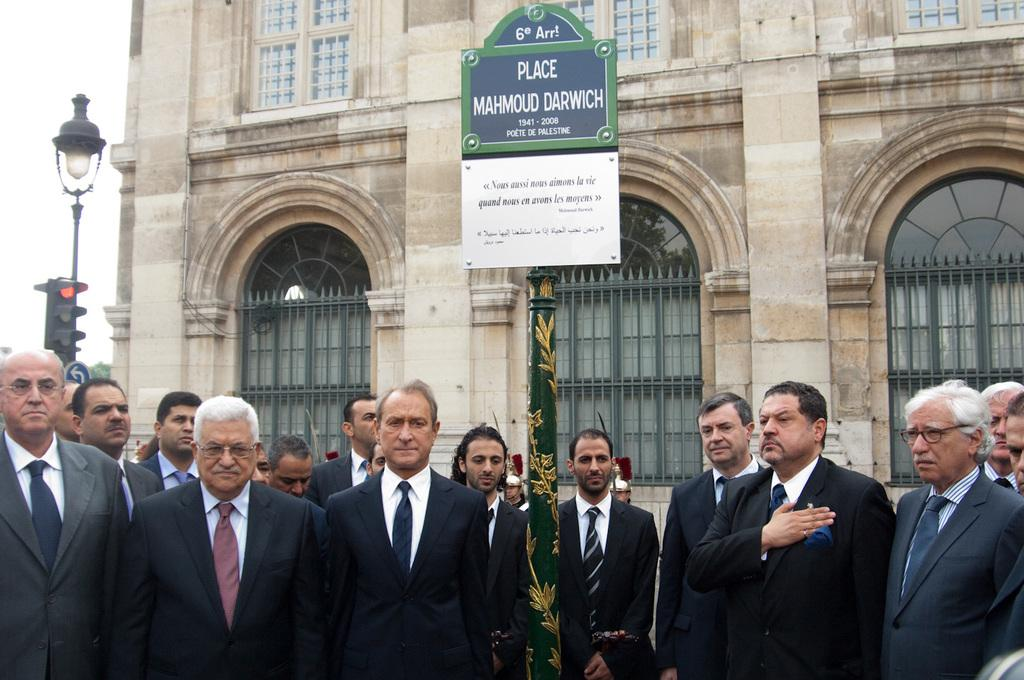What is the main subject of the image? There is a historical landmark of a poet in the image. What are the people in the image doing? A group of men are paying respect to the poet. What other objects can be seen in the image? There is a traffic signal pole and a street light in the image. What type of tooth can be seen in the image? There is no tooth present in the image. How do the men in the image maintain their grip on the poet's statue? The image does not show the men touching or interacting with the statue, so it is not possible to determine how they maintain their grip. 